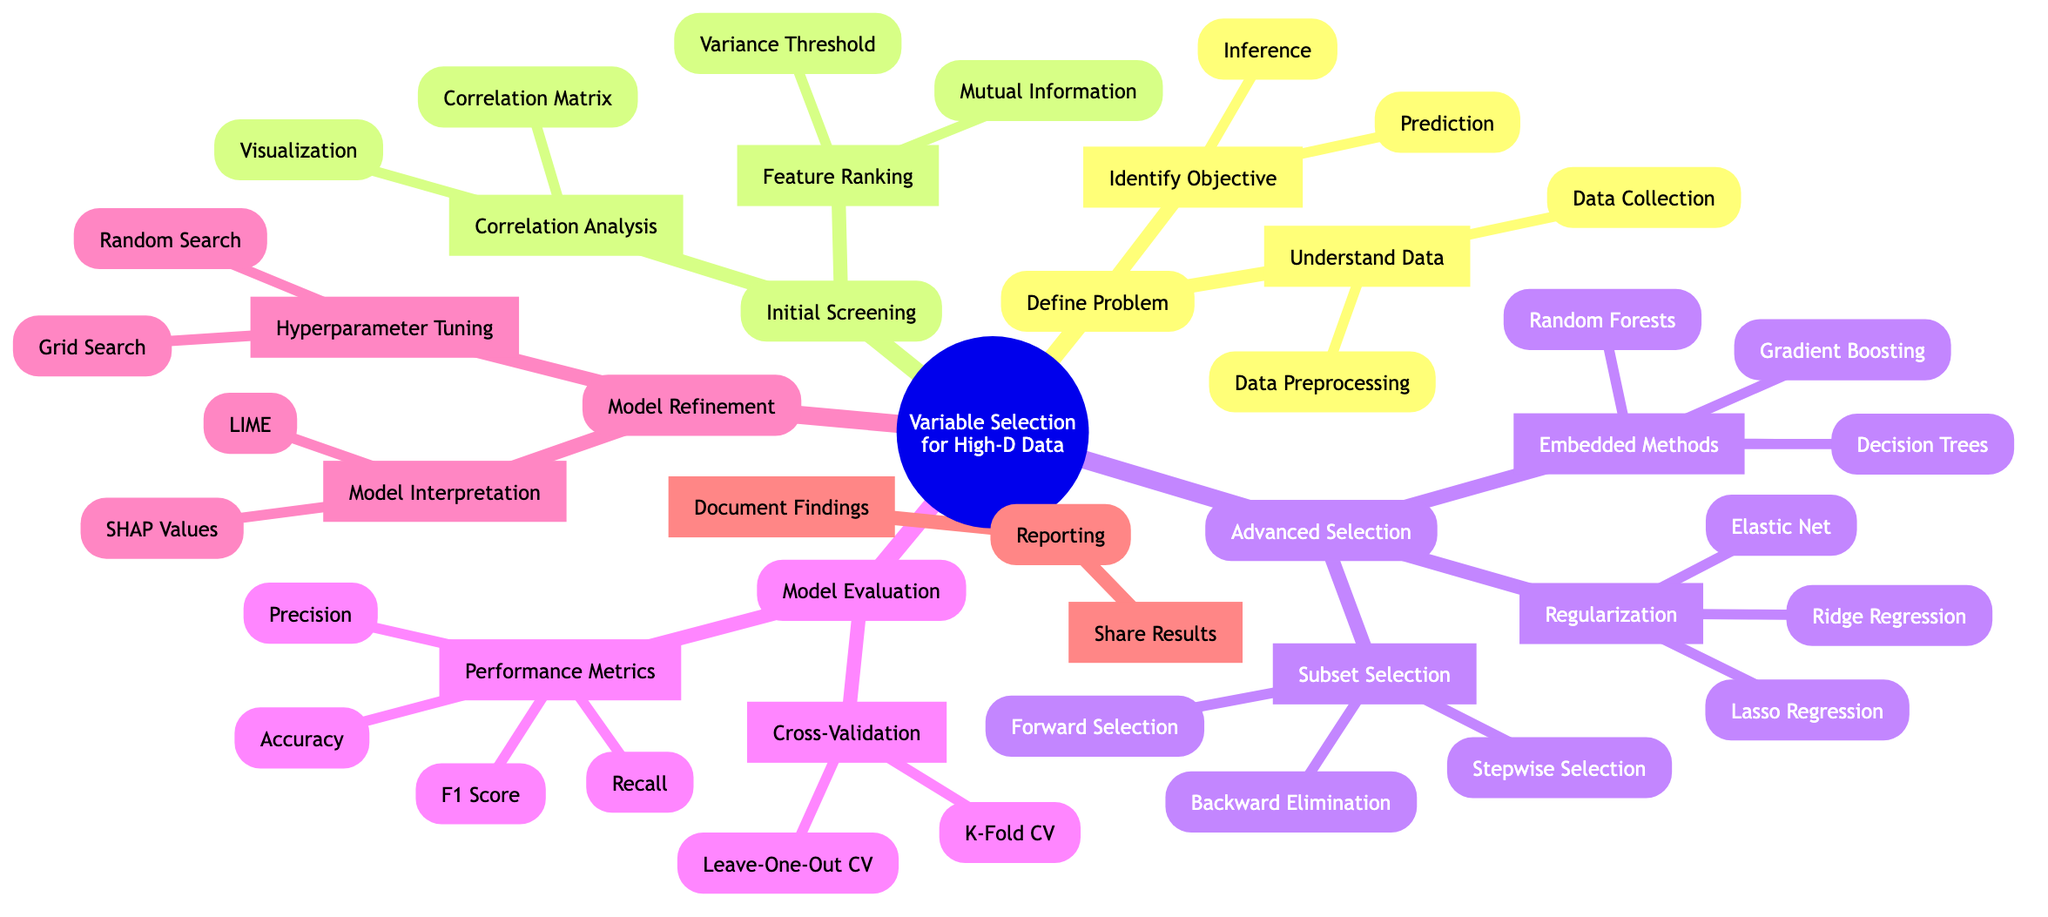What are the two main objectives identified in the diagram for defining the problem? The diagram specifies two main objectives under the "Identify Objective" node: "Prediction" and "Inference."
Answer: Prediction, Inference How many methods are listed under Advanced Feature Selection? In the "Advanced Selection" section, there are three categories: "Regularization Methods," "Embedded Methods," and "Subset Selection," each containing multiple methods. Therefore, when counting all the methods from these categories, there are a total of eight methods listed.
Answer: Eight What is the first step in the Model Evaluation process? The first step in the "Model Evaluation" section is "Cross-Validation," which is followed by "Performance Metrics."
Answer: Cross-Validation Which two types of feature ranking methods are mentioned under Initial Variable Screening? Under the "Feature Ranking" node in the "Initial Screening" section, the two types are "Mutual Information" and "Variance Threshold."
Answer: Mutual Information, Variance Threshold What is the outcome of the "Lasso Regression" method under Advanced Feature Selection? "Lasso Regression" is part of the "Regularization Methods" in the "Advanced Selection" section, which aims to perform variable selection through regularization techniques.
Answer: Variable Selection How many performance metrics are listed in the Model Evaluation section? In the "Performance Metrics" node under the "Model Evaluation" section, we can find four listed metrics: "Accuracy," "Precision," "Recall," and "F1 Score." Thus, there are four performance metrics total.
Answer: Four What are the two methods of Hyperparameter Tuning presented in the diagram? Under the "Hyperparameter Tuning" node in the "Final Model Refinement" section, the two methods listed are "Grid Search" and "Random Search."
Answer: Grid Search, Random Search Which node in the diagram describes the last step of the variable selection process? The last major node in the diagram for the variable selection process is "Reporting," which includes "Document Findings" and "Share Results."
Answer: Reporting 